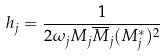<formula> <loc_0><loc_0><loc_500><loc_500>h _ { j } = \frac { 1 } { 2 \omega _ { j } M _ { j } \overline { M } _ { j } ( M _ { j } ^ { * } ) ^ { 2 } }</formula> 